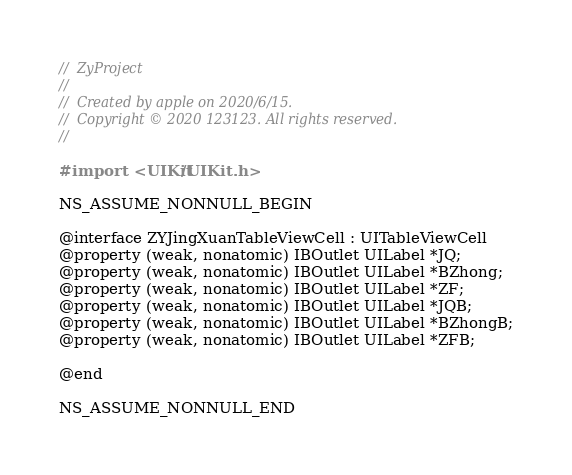Convert code to text. <code><loc_0><loc_0><loc_500><loc_500><_C_>//  ZyProject
//
//  Created by apple on 2020/6/15.
//  Copyright © 2020 123123. All rights reserved.
//

#import <UIKit/UIKit.h>

NS_ASSUME_NONNULL_BEGIN

@interface ZYJingXuanTableViewCell : UITableViewCell
@property (weak, nonatomic) IBOutlet UILabel *JQ;
@property (weak, nonatomic) IBOutlet UILabel *BZhong;
@property (weak, nonatomic) IBOutlet UILabel *ZF;
@property (weak, nonatomic) IBOutlet UILabel *JQB;
@property (weak, nonatomic) IBOutlet UILabel *BZhongB;
@property (weak, nonatomic) IBOutlet UILabel *ZFB;

@end

NS_ASSUME_NONNULL_END
</code> 